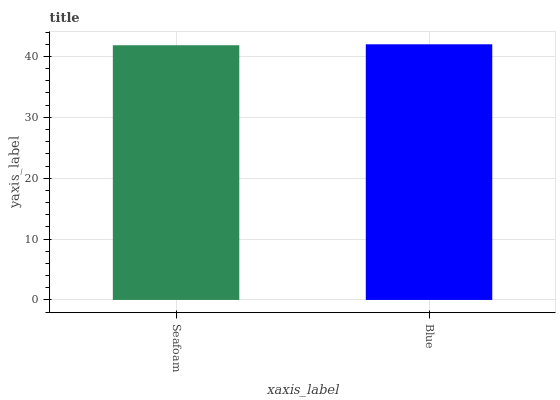Is Blue the minimum?
Answer yes or no. No. Is Blue greater than Seafoam?
Answer yes or no. Yes. Is Seafoam less than Blue?
Answer yes or no. Yes. Is Seafoam greater than Blue?
Answer yes or no. No. Is Blue less than Seafoam?
Answer yes or no. No. Is Blue the high median?
Answer yes or no. Yes. Is Seafoam the low median?
Answer yes or no. Yes. Is Seafoam the high median?
Answer yes or no. No. Is Blue the low median?
Answer yes or no. No. 